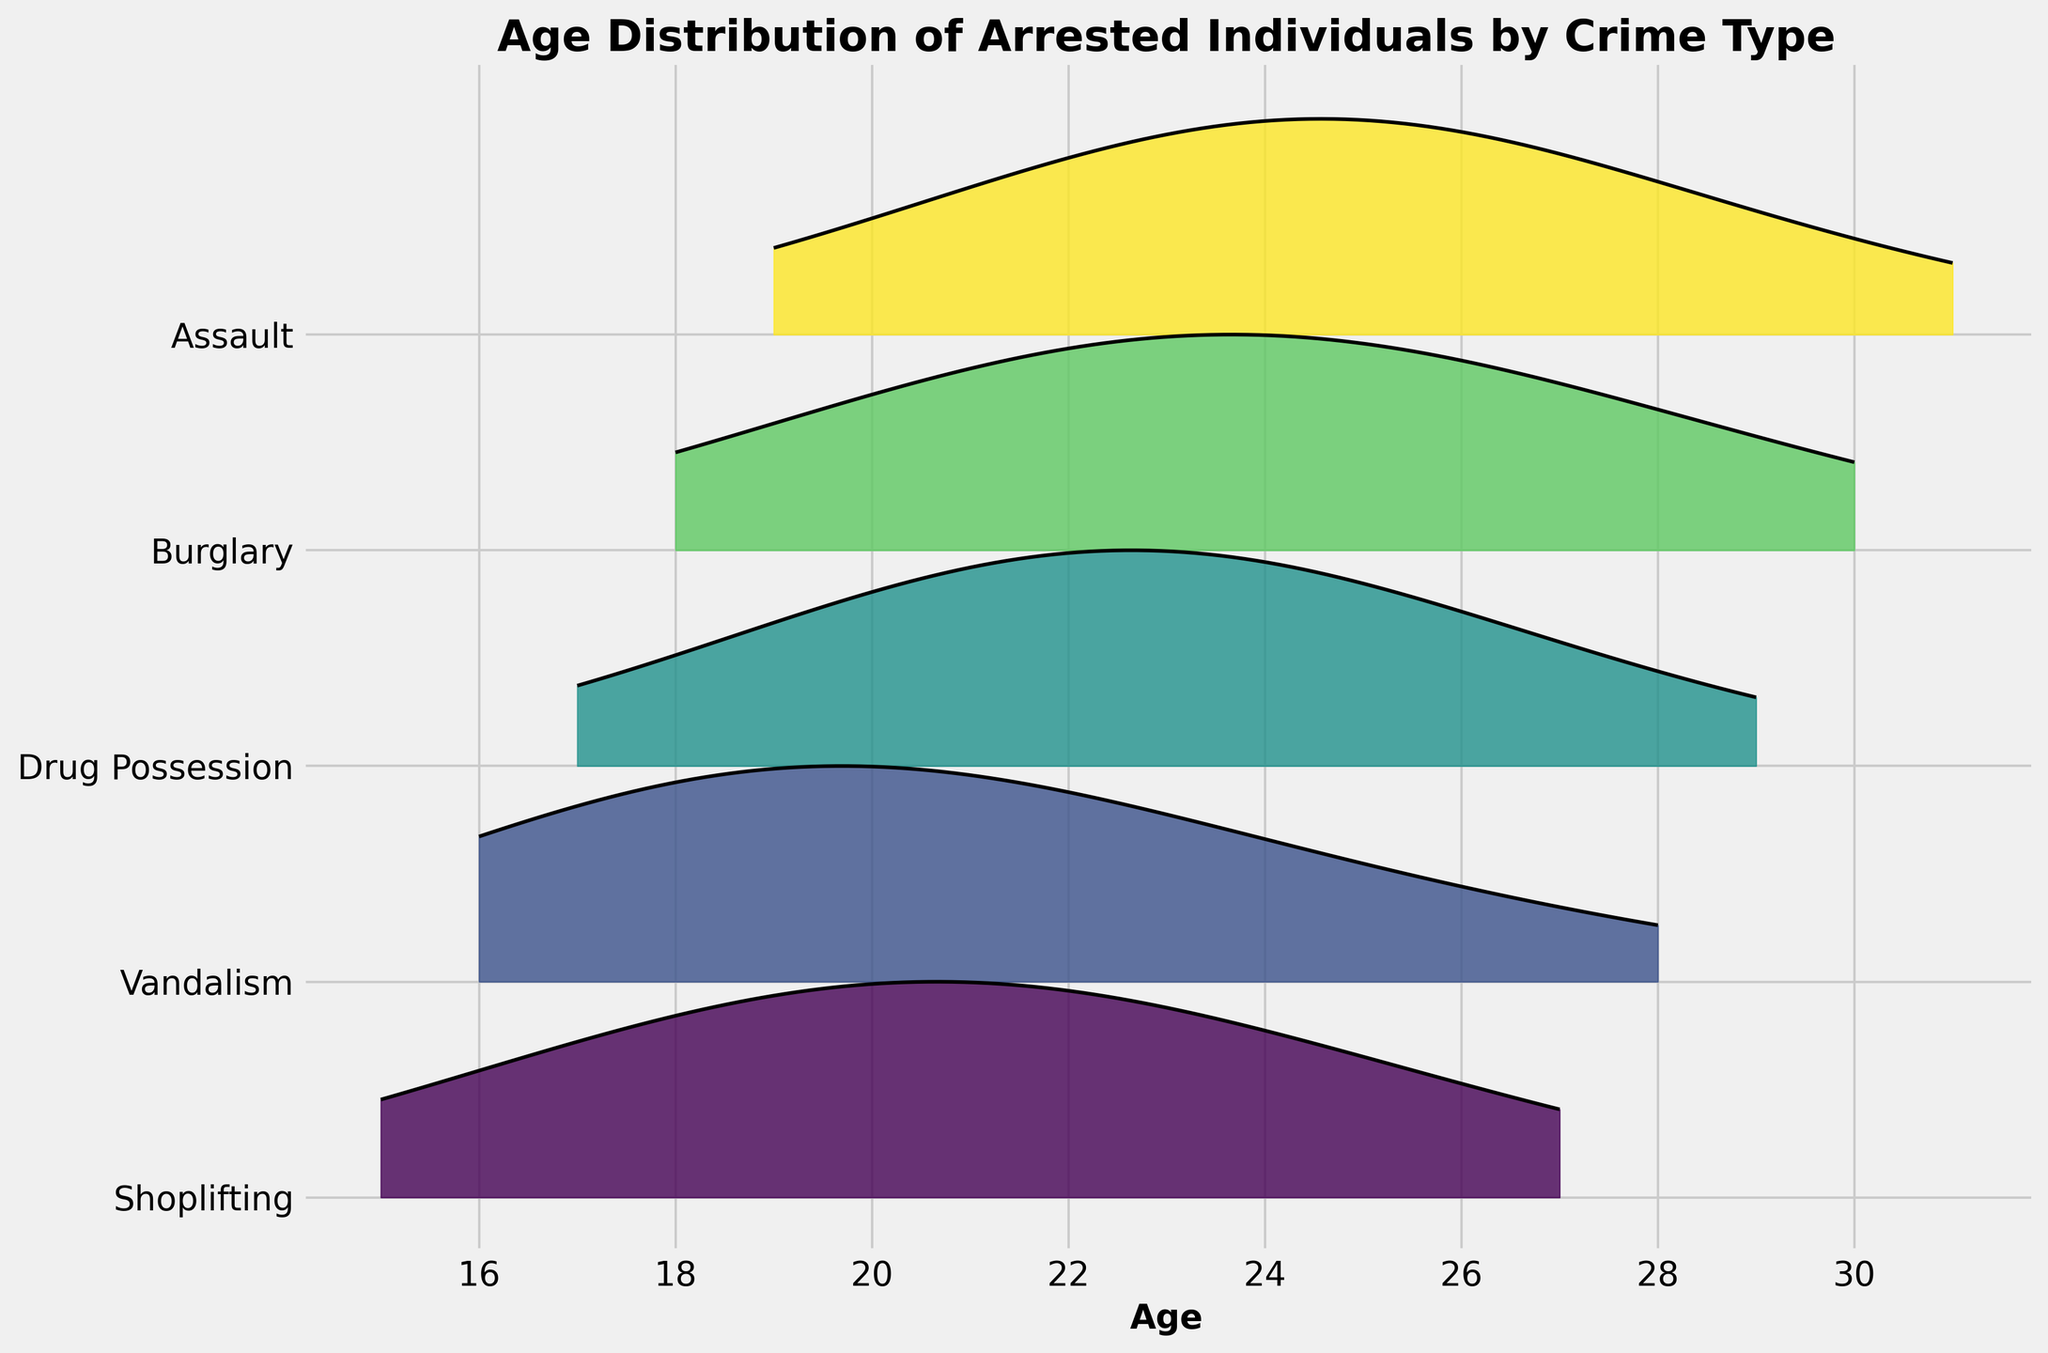What is the title of the plot? The title is typically displayed at the top of the plot and is meant to provide an overview of what the plot represents. In this case, look at the top center of the plot to find the title.
Answer: Age Distribution of Arrested Individuals by Crime Type What does the x-axis represent? The x-axis label is usually written along the horizontal axis at the bottom of the plot. For this plot, check what the label of the x-axis indicates.
Answer: Age Which crime types are included in the plot? The ridgeline plot has multiple layers, each representing a different crime type. Look at the y-axis to see the labels for each layer indicating the different crime types.
Answer: Shoplifting, Vandalism, Drug Possession, Burglary, Assault Among the crime types, which one has the highest density peak? Identify the ridgeline plot with the tallest peak, as this indicates the highest density for a particular age group. Determine which crime type that ridge corresponds to by checking the y-axis labels.
Answer: Shoplifting At what age does the density peak for vandalism? To find the peak density for vandalism, look at the ridgeline labeled "Vandalism" and identify the age on the x-axis corresponding to its highest point.
Answer: 19 Which crime has a density peak at age 24? To determine which crime peaks at age 24, examine the ridgelines at the x-axis value of 24 and check for the highest density. Trace back to see which y-axis label corresponds to this peak.
Answer: Shoplifting and Burglary What's the range of ages covered for drug possession arrests? To find the age range, look at the ridgeline labeled "Drug Possession" and note the minimum and maximum ages where the density is non-zero.
Answer: 17 to 29 Which crime type shows the most uniform distribution of ages? Uniform distribution means the density is spread out across ages rather than peaking sharply. Find the ridgeline that is flatter and more evenly spread across different ages.
Answer: Assault Comparing shoplifting and burglary, which age group has a higher density for shoplifting? To compare densities between shoplifting and burglary, look at the peaks and their corresponding x-axis values on both ridgelines. Identify which age group has a higher density in the shoplifting ridgeline.
Answer: 21 How does the density for ages 18 and 21 compare within the shoplifting crime type? Look at the shoplifting ridgeline and compare the height of the density at ages 18 and 21 to determine which one is larger.
Answer: Age 21 has a higher density than age 18 